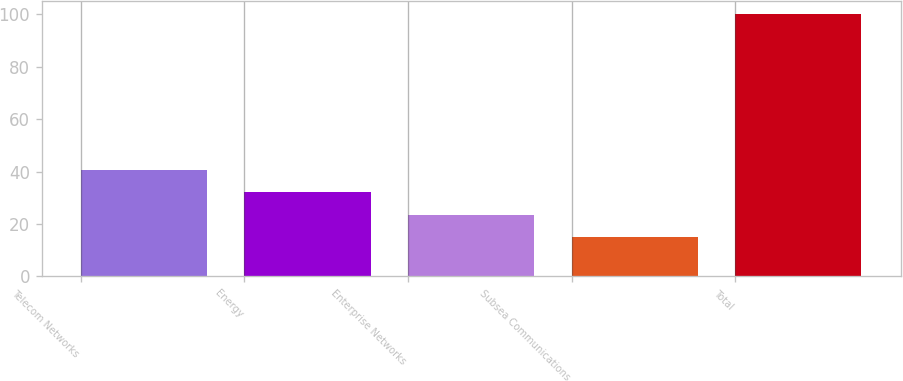Convert chart to OTSL. <chart><loc_0><loc_0><loc_500><loc_500><bar_chart><fcel>Telecom Networks<fcel>Energy<fcel>Enterprise Networks<fcel>Subsea Communications<fcel>Total<nl><fcel>40.5<fcel>32<fcel>23.5<fcel>15<fcel>100<nl></chart> 